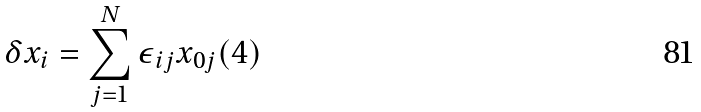Convert formula to latex. <formula><loc_0><loc_0><loc_500><loc_500>\delta x _ { i } = \sum _ { j = 1 } ^ { N } \epsilon _ { i j } x _ { 0 j } ( 4 )</formula> 